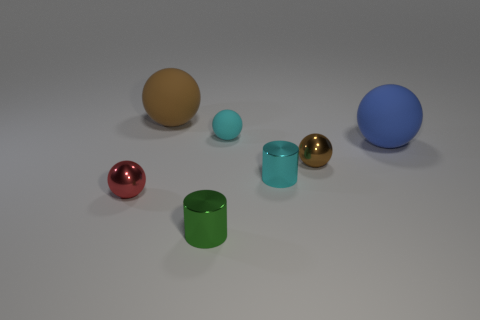What number of other things are the same shape as the green thing?
Provide a short and direct response. 1. Is the shape of the object that is in front of the small red shiny sphere the same as the small cyan object in front of the tiny cyan matte object?
Keep it short and to the point. Yes. What number of cylinders are either red objects or small cyan metallic things?
Provide a short and direct response. 1. There is a big ball that is on the right side of the cylinder that is on the right side of the tiny cyan matte ball behind the big blue ball; what is it made of?
Make the answer very short. Rubber. What number of other things are there of the same size as the green metal cylinder?
Offer a terse response. 4. There is a object that is the same color as the small rubber ball; what is its size?
Provide a succinct answer. Small. Are there more shiny things behind the small brown sphere than tiny matte balls?
Provide a succinct answer. No. Are there any small cylinders that have the same color as the tiny matte ball?
Ensure brevity in your answer.  Yes. The rubber ball that is the same size as the brown metallic thing is what color?
Your answer should be compact. Cyan. There is a object on the left side of the brown rubber object; what number of small metal cylinders are in front of it?
Offer a very short reply. 1. 